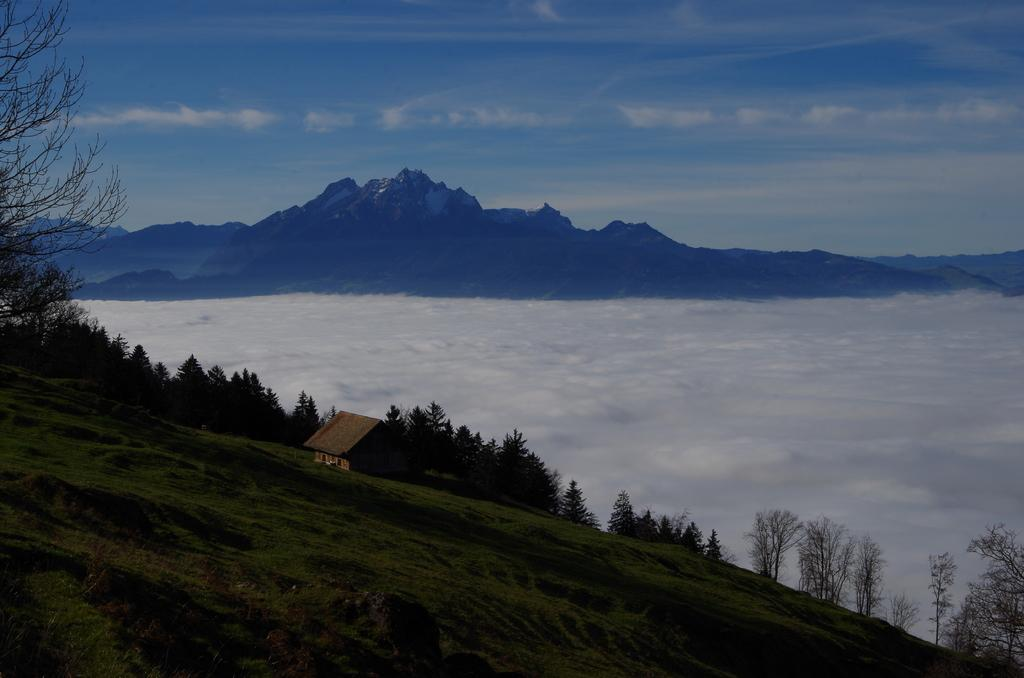What type of terrain is depicted in the image? There is slope land in the image. What structures can be seen on the slope land? There is a house on the slope land. What type of vegetation is present on the slope land? There are trees on the slope land. What can be seen in the background of the image? There is snow visible in the background, along with mountains and the sky. What type of poison is being used to protect the trees in the image? There is no mention of poison or any protective measures for the trees in the image. 